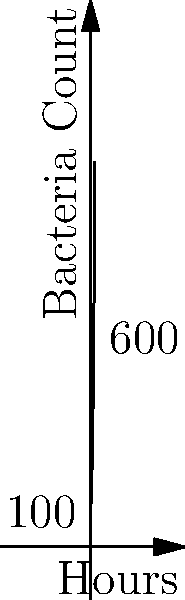In a hospital ward, a bacterial outbreak is detected. Initially, there are 100 bacteria, and the population doubles every 3.5 hours. Using the exponential growth model, how many bacteria will there be after 12 hours? Round your answer to the nearest whole number. Let's approach this step-by-step:

1) The exponential growth model is given by the formula:
   
   $N(t) = N_0 \cdot e^{rt}$

   Where:
   $N(t)$ is the number of bacteria at time $t$
   $N_0$ is the initial number of bacteria
   $r$ is the growth rate
   $t$ is the time elapsed

2) We know:
   $N_0 = 100$ (initial bacteria)
   $t = 12$ hours

3) To find $r$, we use the doubling time formula:
   
   $\text{Doubling Time} = \frac{\ln(2)}{r}$

   $3.5 = \frac{\ln(2)}{r}$
   
   $r = \frac{\ln(2)}{3.5} \approx 0.198$

4) Now we can plug these values into our exponential growth formula:

   $N(12) = 100 \cdot e^{0.198 \cdot 12}$

5) Calculate:
   $N(12) = 100 \cdot e^{2.376} \approx 100 \cdot 10.76 \approx 1076$

6) Rounding to the nearest whole number: 1076
Answer: 1076 bacteria 